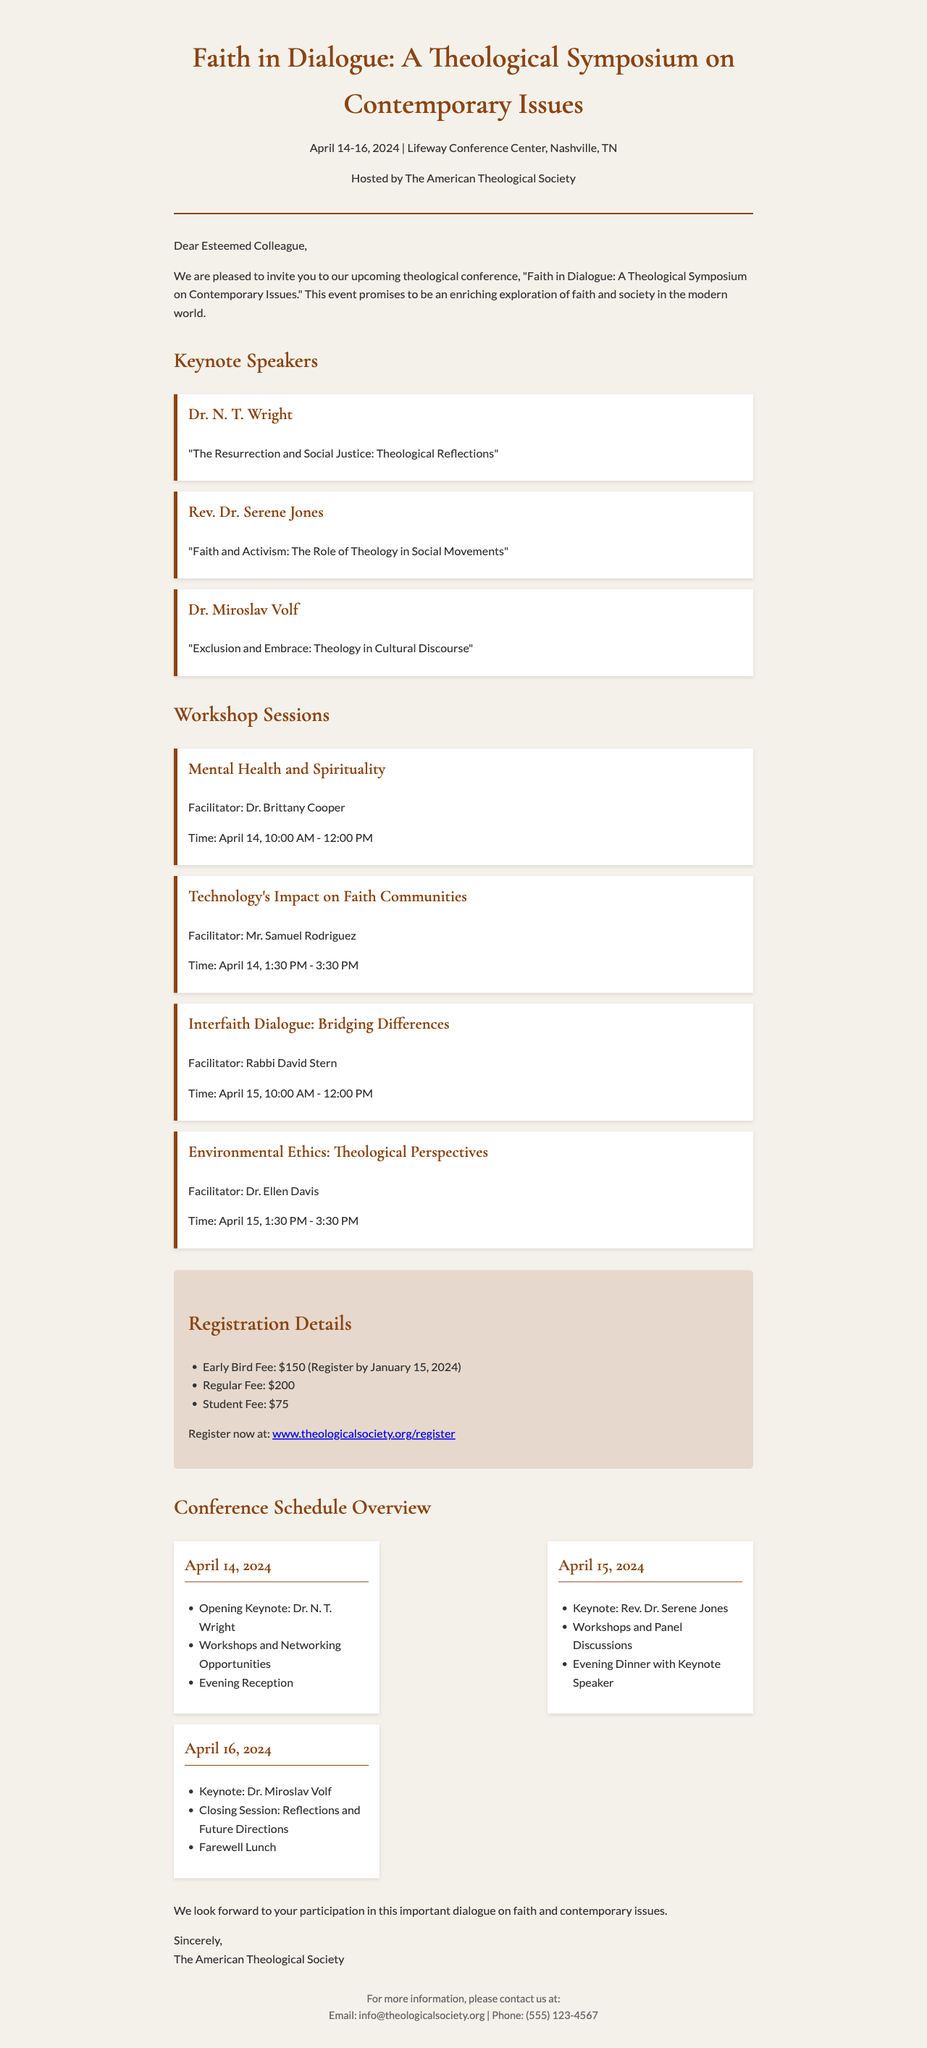What is the title of the conference? The title is found in the header of the document, which states "Faith in Dialogue: A Theological Symposium on Contemporary Issues."
Answer: Faith in Dialogue: A Theological Symposium on Contemporary Issues When is the conference scheduled? The dates of the conference are mentioned in the header as April 14-16, 2024.
Answer: April 14-16, 2024 Who is the host of this conference? The host organization is identified in the header of the document as The American Theological Society.
Answer: The American Theological Society What is the early bird registration fee? The registration details specify the early bird fee is $150 if registered by January 15, 2024.
Answer: $150 What is one of the workshop topics? The workshop topics are listed under "Workshop Sessions," and "Mental Health and Spirituality" is one such topic.
Answer: Mental Health and Spirituality Who is the facilitator of the session on technology's impact? The facilitator is named in the workshop section, specifically for the topic "Technology's Impact on Faith Communities."
Answer: Mr. Samuel Rodriguez What will happen on April 15, 2024? The schedule provides that there will be a keynote and workshops, indicating activities that will take place on this date.
Answer: Keynote and workshops What is the last event of the conference? The schedule indicates that on the final day, the last event is a farewell lunch.
Answer: Farewell Lunch 